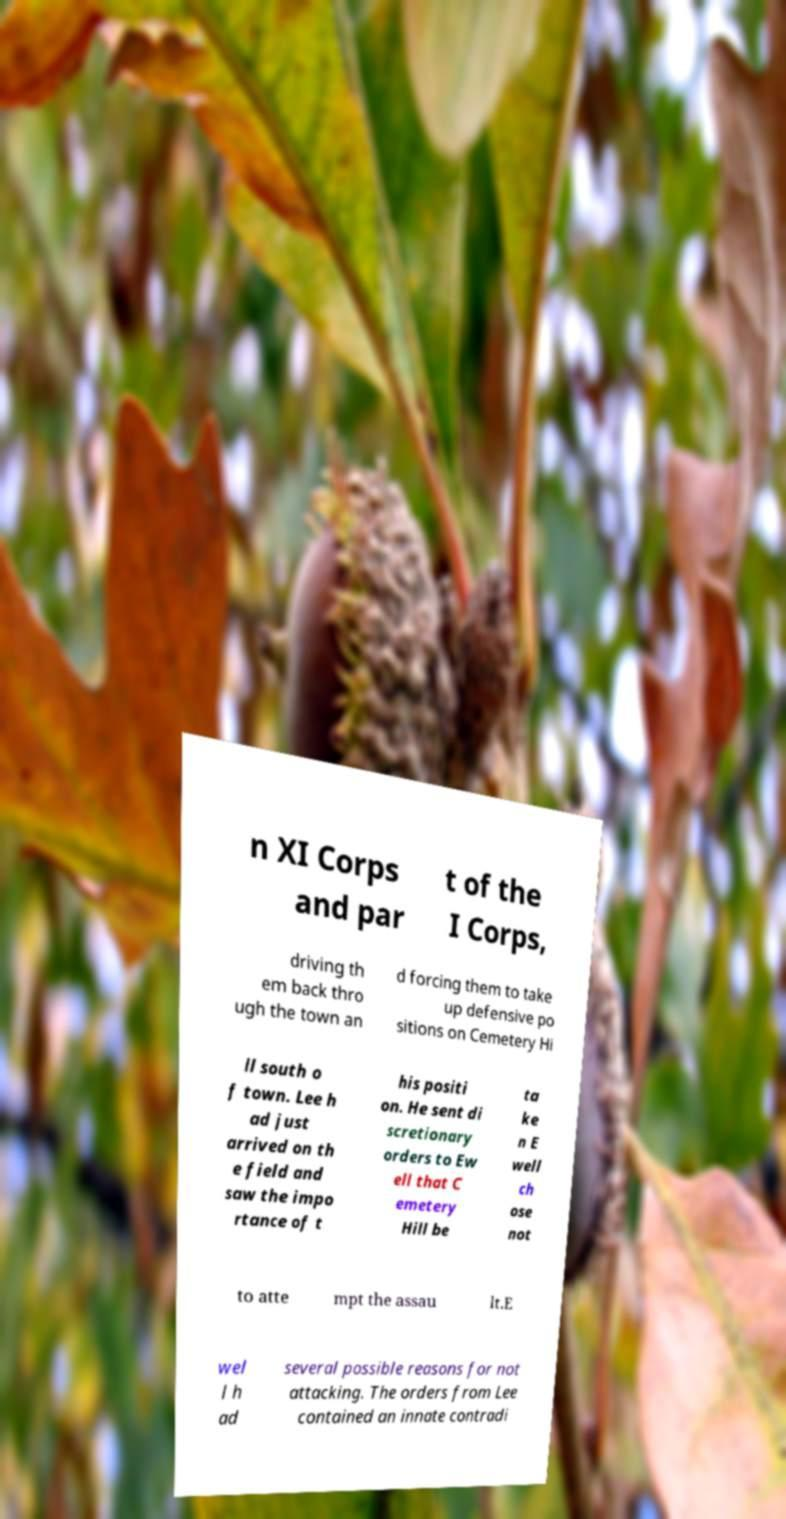Could you assist in decoding the text presented in this image and type it out clearly? n XI Corps and par t of the I Corps, driving th em back thro ugh the town an d forcing them to take up defensive po sitions on Cemetery Hi ll south o f town. Lee h ad just arrived on th e field and saw the impo rtance of t his positi on. He sent di scretionary orders to Ew ell that C emetery Hill be ta ke n E well ch ose not to atte mpt the assau lt.E wel l h ad several possible reasons for not attacking. The orders from Lee contained an innate contradi 